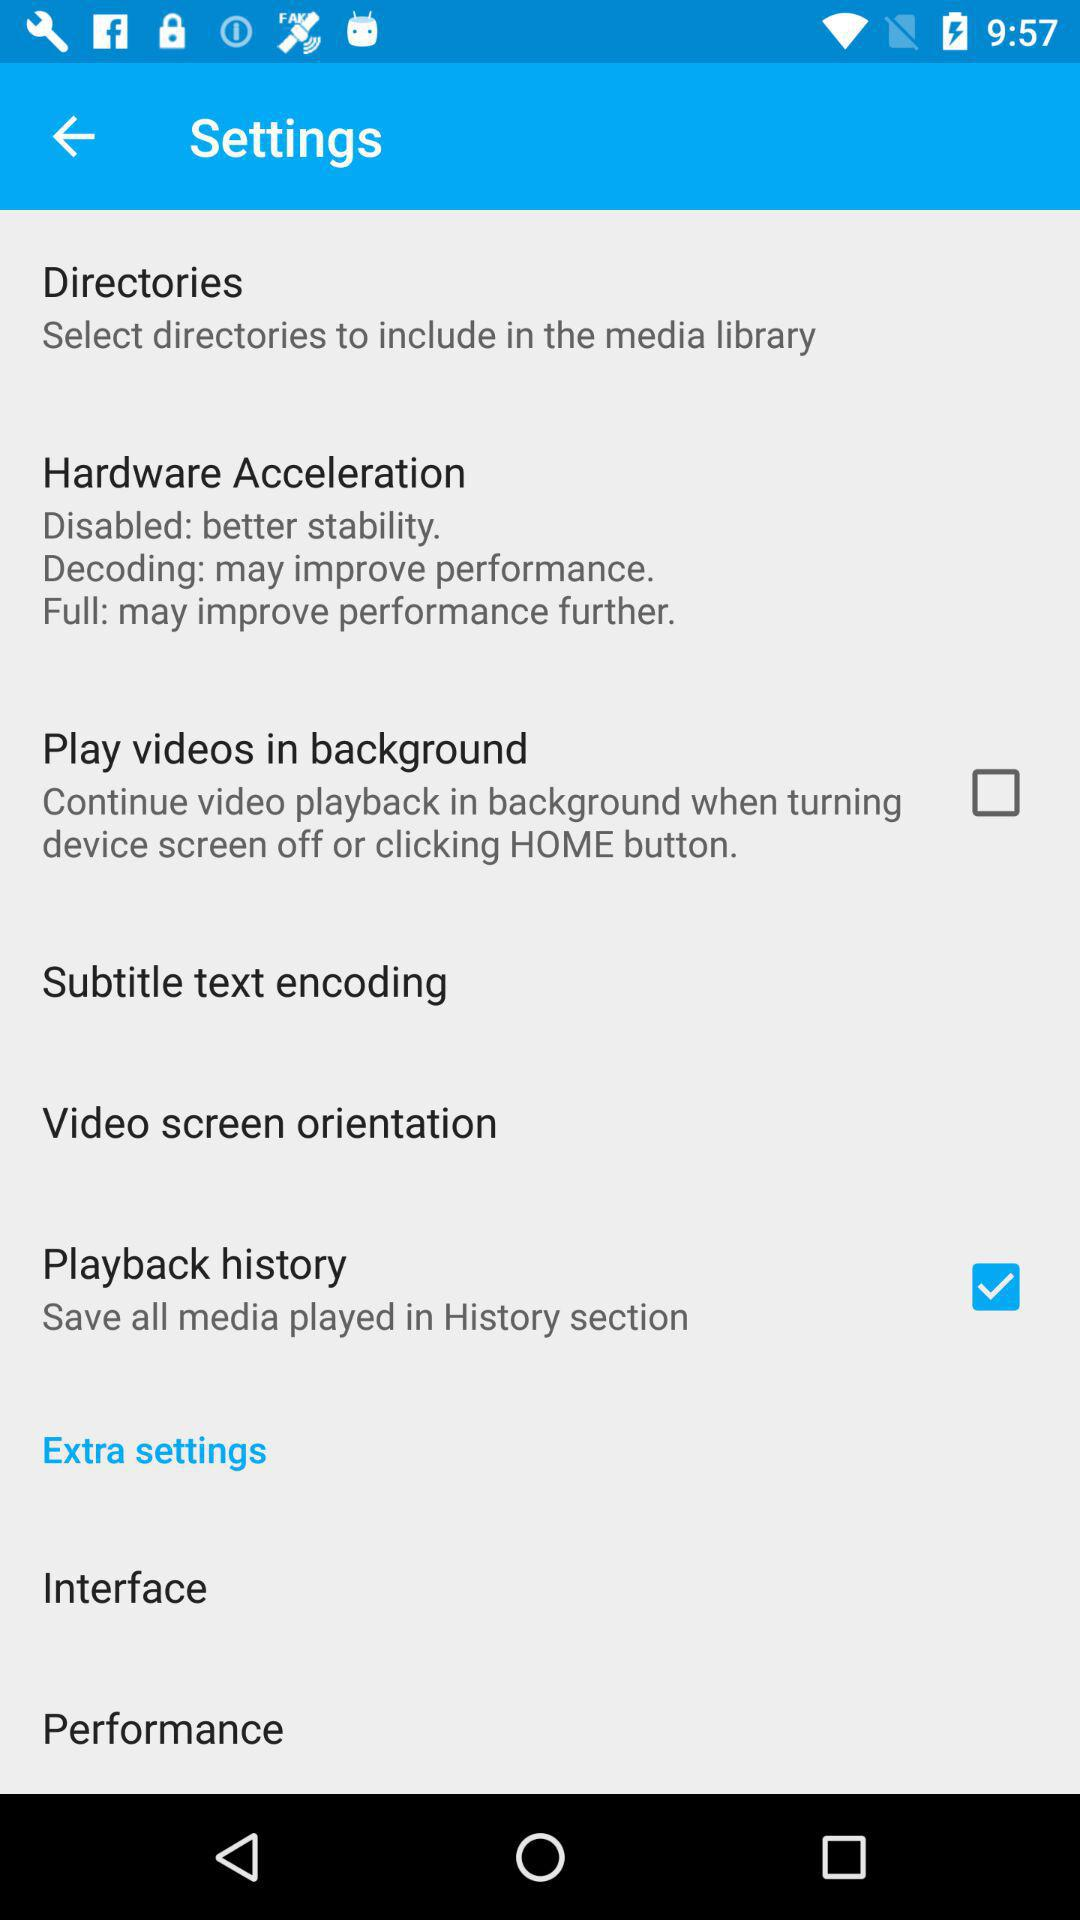How many dB does the 31 Hz band have compared to the 1kHz band?
Answer the question using a single word or phrase. 0.0 